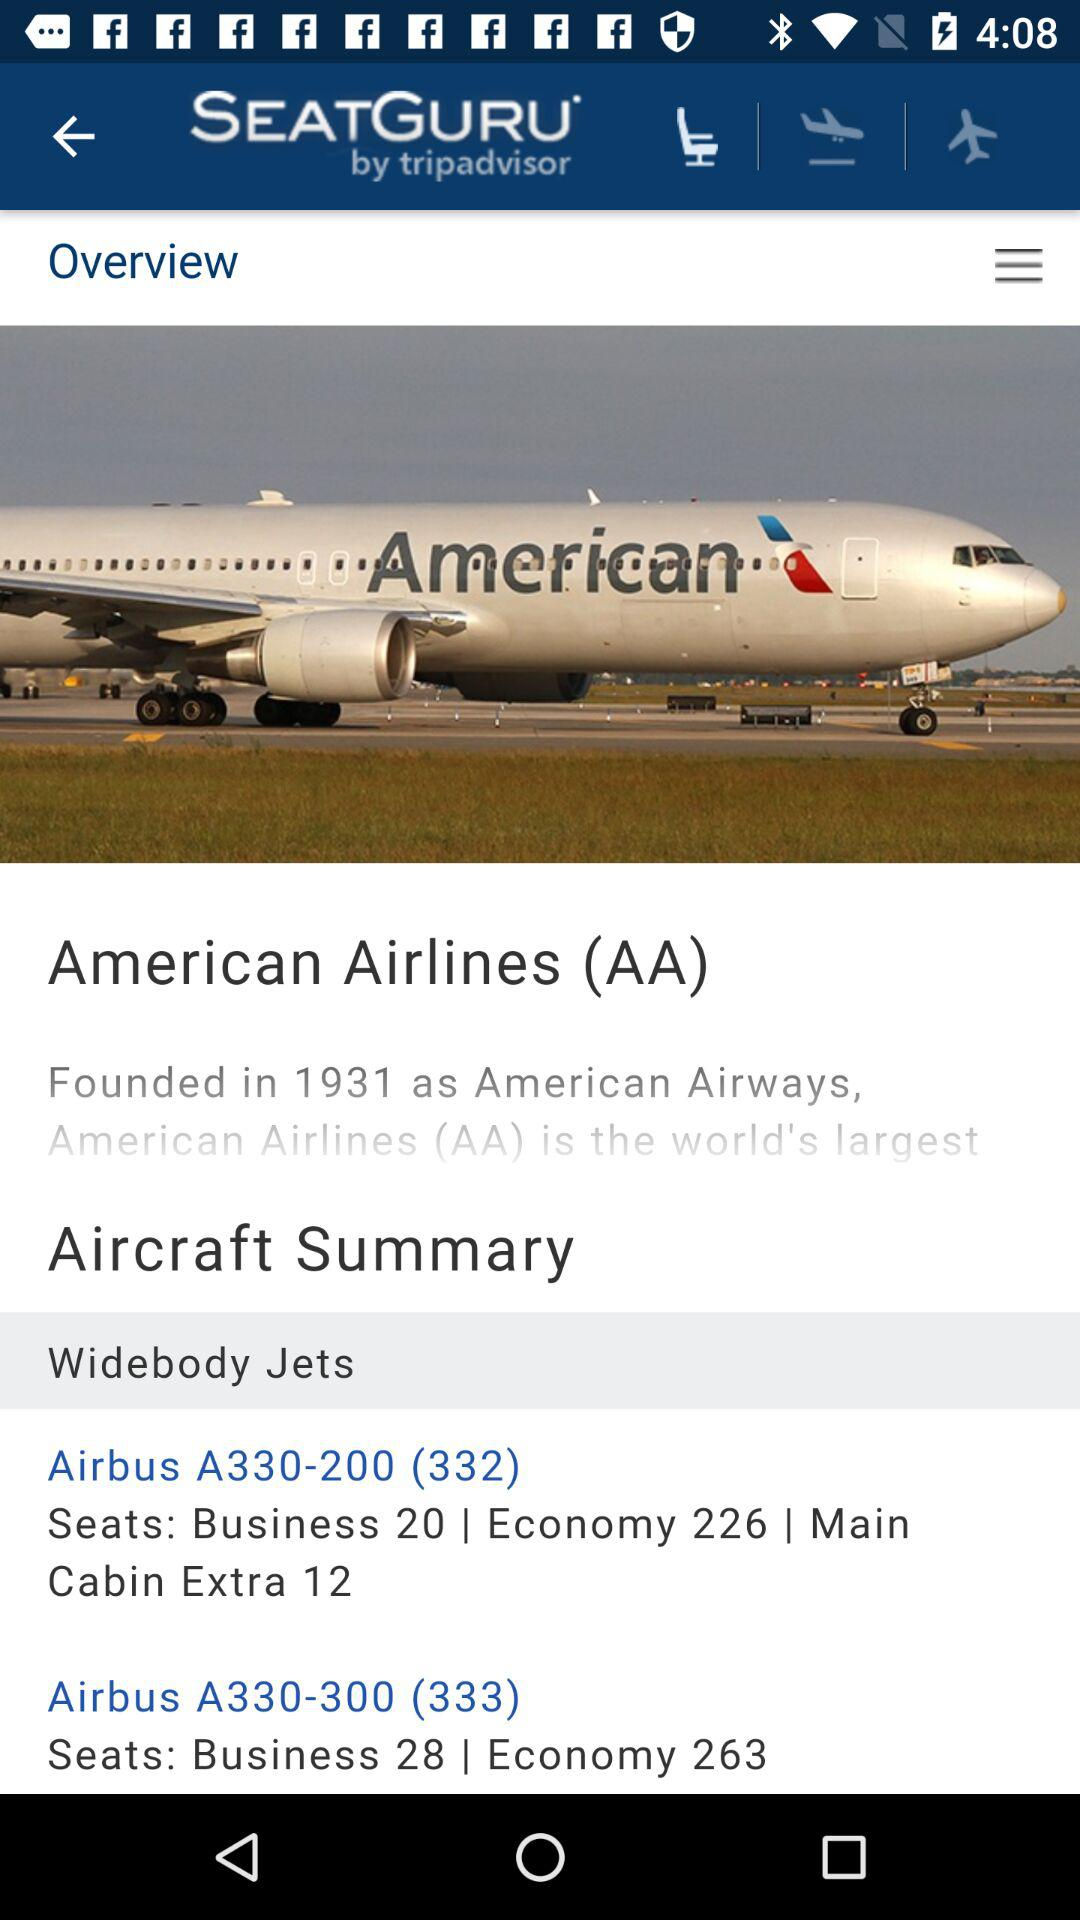What are the jet names? The jet names are "Airbus A330-200 (332)" and "Airbus A330-300 (333)". 